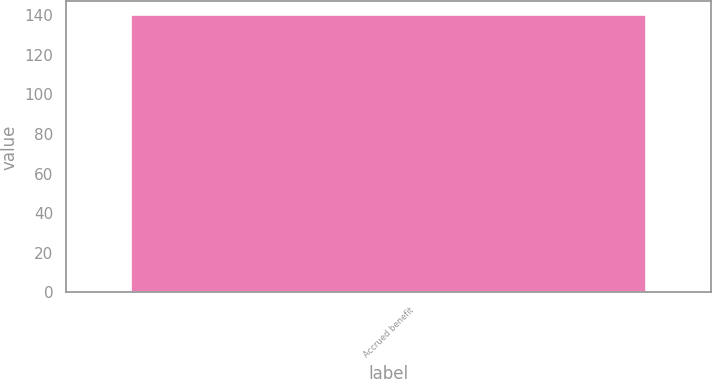Convert chart to OTSL. <chart><loc_0><loc_0><loc_500><loc_500><bar_chart><fcel>Accrued benefit<nl><fcel>140<nl></chart> 